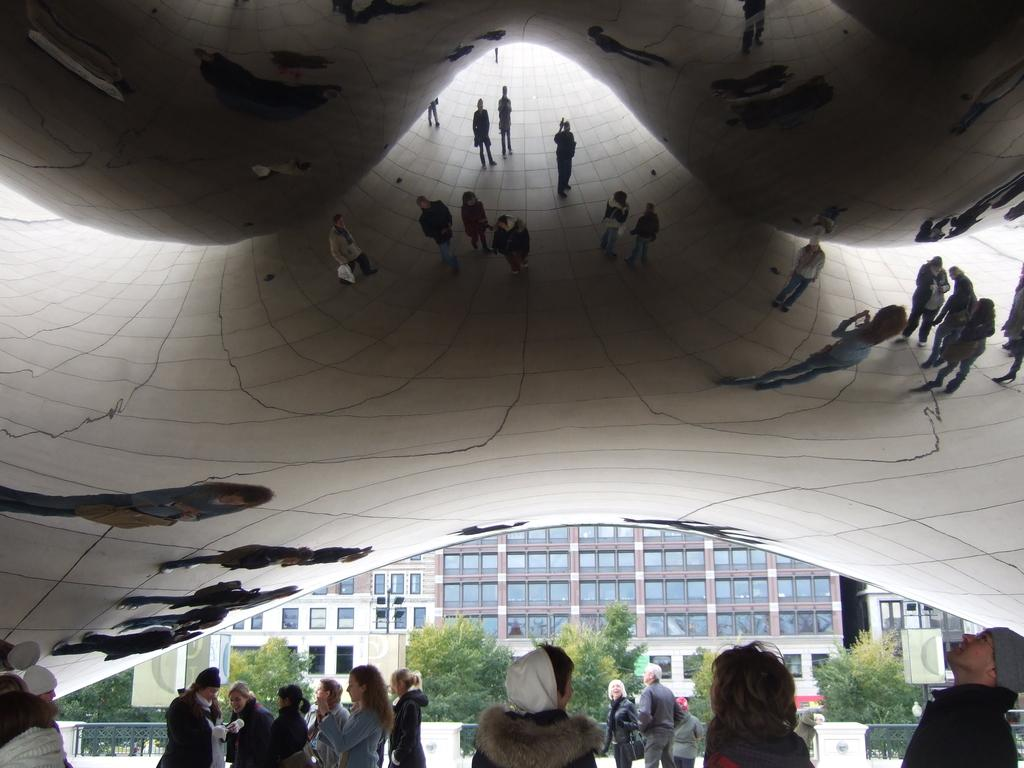What are the people at the bottom of the image doing? The people at the bottom of the image are standing and talking. What can be seen in the middle of the image? There are trees and a very big building in the middle of the image. Can you describe the shape of the mirror at the top of the image? The mirror at the top of the image is in a Zigzag shape. What type of tail can be seen on the building in the image? There is no tail present on the building in the image. Do the people at the bottom of the image believe in the existence of the mirror at the top of the image? The image does not provide information about the beliefs of the people at the bottom of the image. Who is the representative of the trees in the middle of the image? The image does not depict a representative for the trees. 